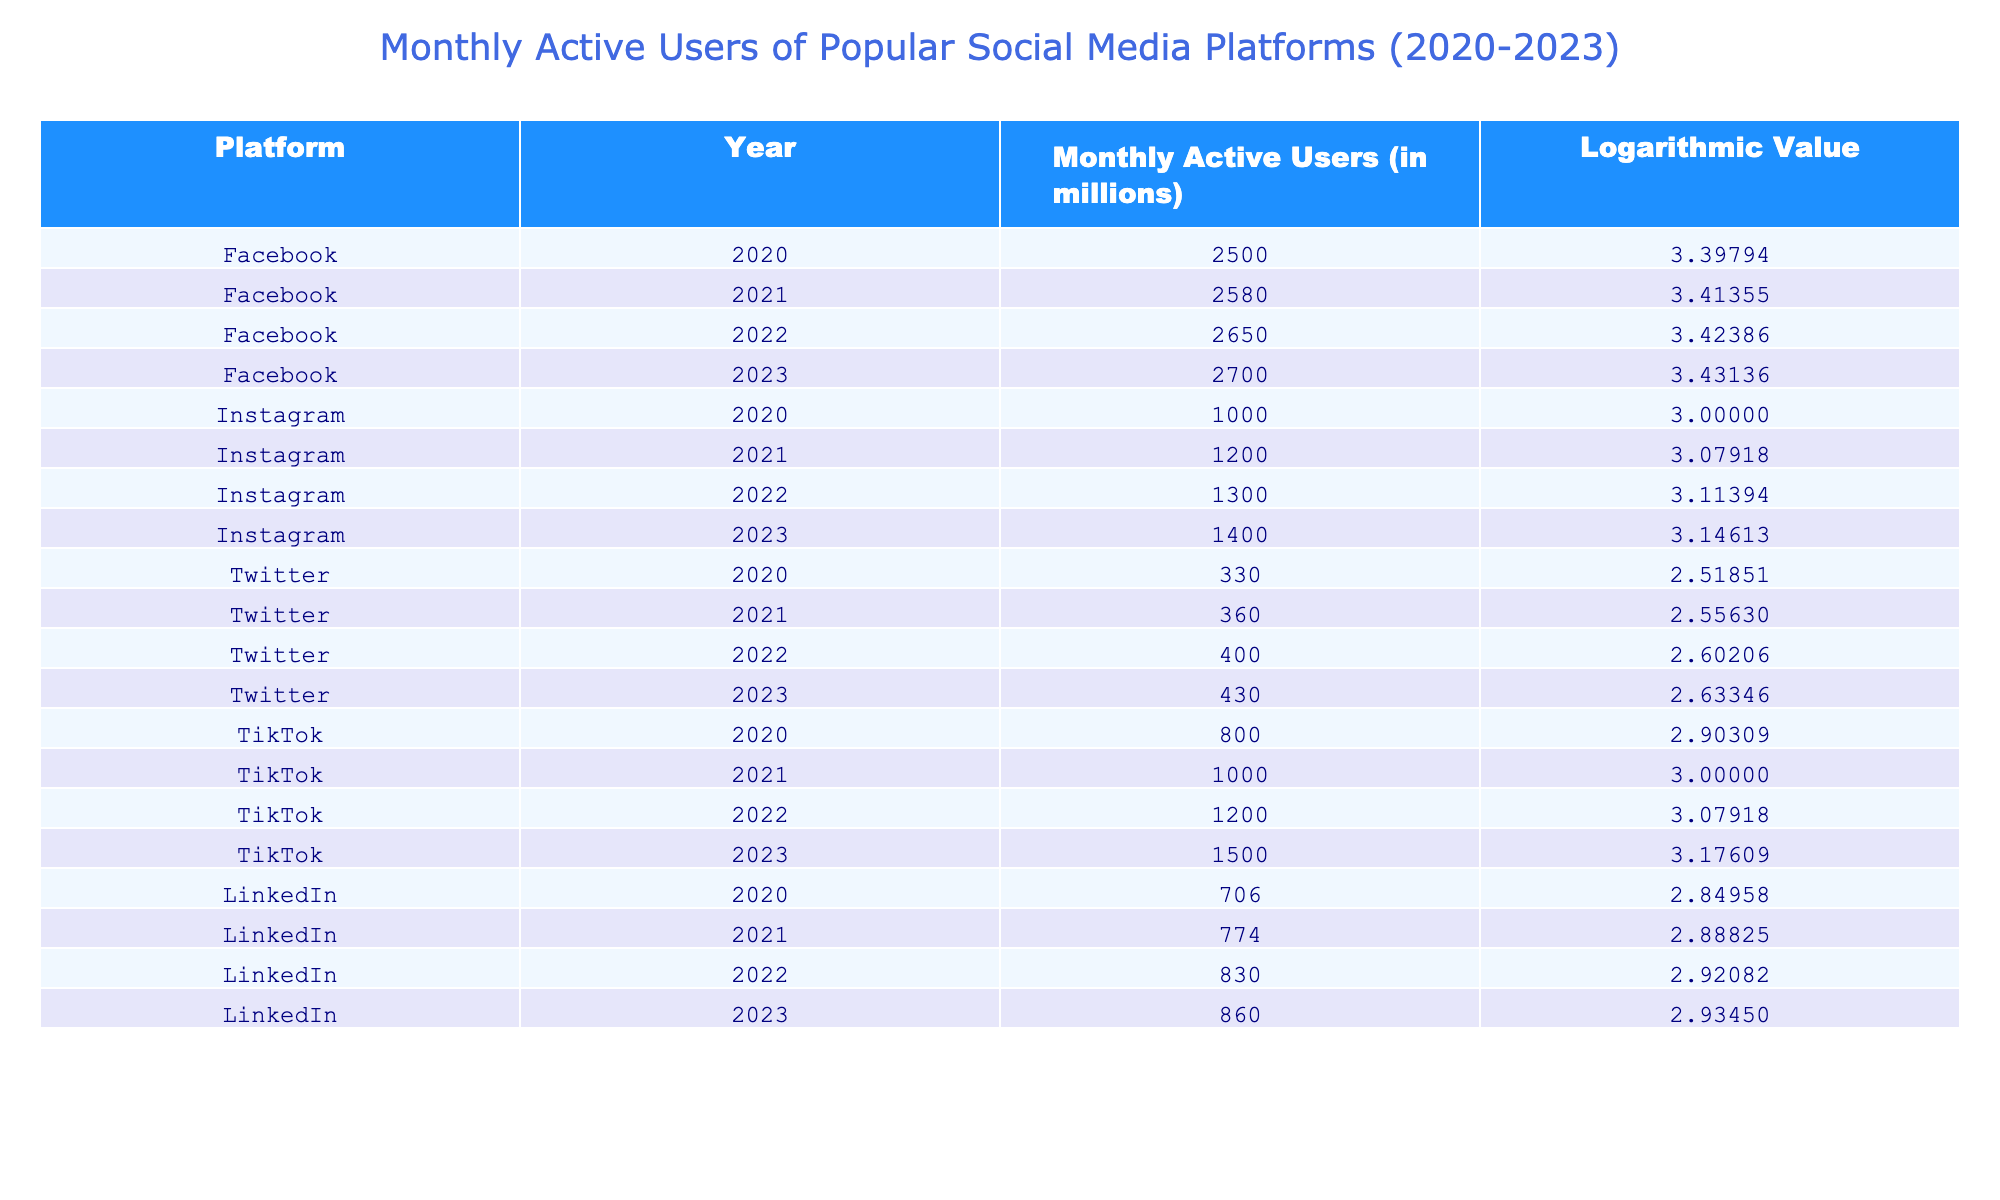What was the Monthly Active Users for Facebook in 2022? The table shows that in 2022, Facebook had 2650 million Monthly Active Users.
Answer: 2650 million What was the logarithmic value for TikTok in 2021? Referring to the table, the logarithmic value for TikTok in 2021 is 3.00000.
Answer: 3.00000 Which platform had the highest Monthly Active Users in 2023? Comparing the values in the table for 2023, Facebook has the highest Monthly Active Users at 2700 million.
Answer: Facebook What is the difference in Monthly Active Users between Instagram and LinkedIn in 2023? In 2023, Instagram had 1400 million and LinkedIn had 860 million. The difference is 1400 - 860 = 540 million.
Answer: 540 million Is the logarithmic value for Twitter in 2022 greater than that in 2021? The table shows the logarithmic value for Twitter in 2022 is 2.60206, while in 2021 it is 2.55630. Since 2.60206 is greater than 2.55630, the answer is yes.
Answer: Yes What is the average Monthly Active Users for TikTok from 2020 to 2023? Adding the Monthly Active Users: 800 + 1000 + 1200 + 1500 = 3500 million. There are 4 data points, so the average is 3500 / 4 = 875 million.
Answer: 875 million Which platform showed the largest increase in Monthly Active Users from 2020 to 2023? Analyzing the data, Facebook increased from 2500 million to 2700 million (200 million increase), Instagram from 1000 million to 1400 million (400 million increase), Twitter from 330 million to 430 million (100 million increase), TikTok from 800 million to 1500 million (700 million increase), and LinkedIn from 706 million to 860 million (154 million increase). Therefore, TikTok had the largest increase at 700 million.
Answer: TikTok Was the logarithmic value for Facebook in 2023 lower than its value in 2020? The table indicates that the logarithmic value for Facebook in 2023 is 3.43136 and in 2020 it was 3.39794. Since 3.43136 is greater, the answer is no.
Answer: No 